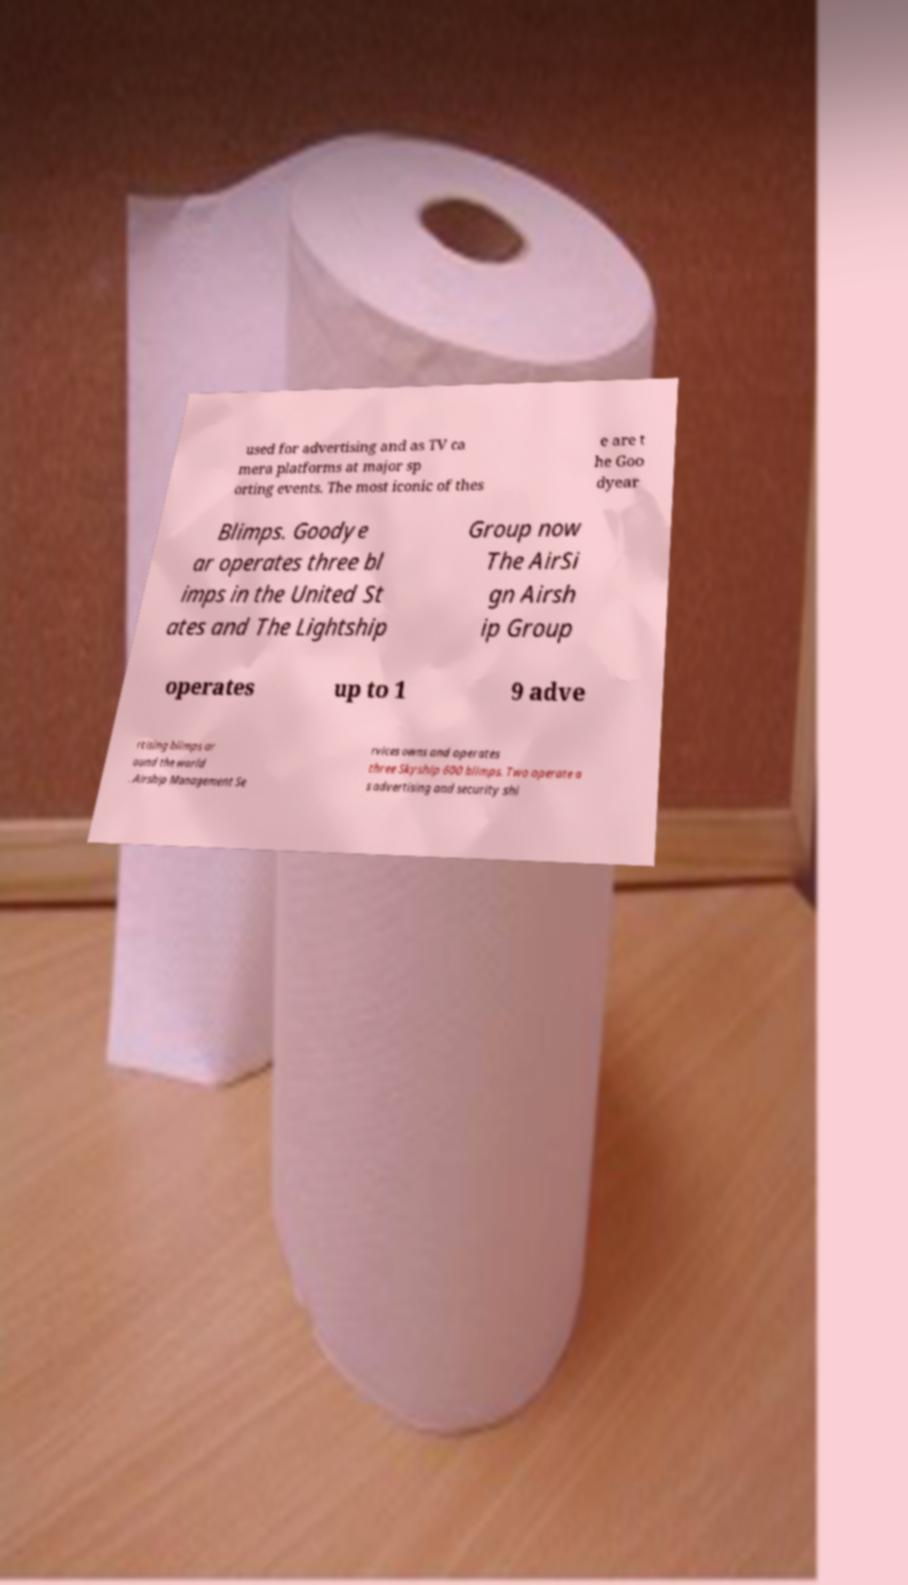I need the written content from this picture converted into text. Can you do that? used for advertising and as TV ca mera platforms at major sp orting events. The most iconic of thes e are t he Goo dyear Blimps. Goodye ar operates three bl imps in the United St ates and The Lightship Group now The AirSi gn Airsh ip Group operates up to 1 9 adve rtising blimps ar ound the world . Airship Management Se rvices owns and operates three Skyship 600 blimps. Two operate a s advertising and security shi 